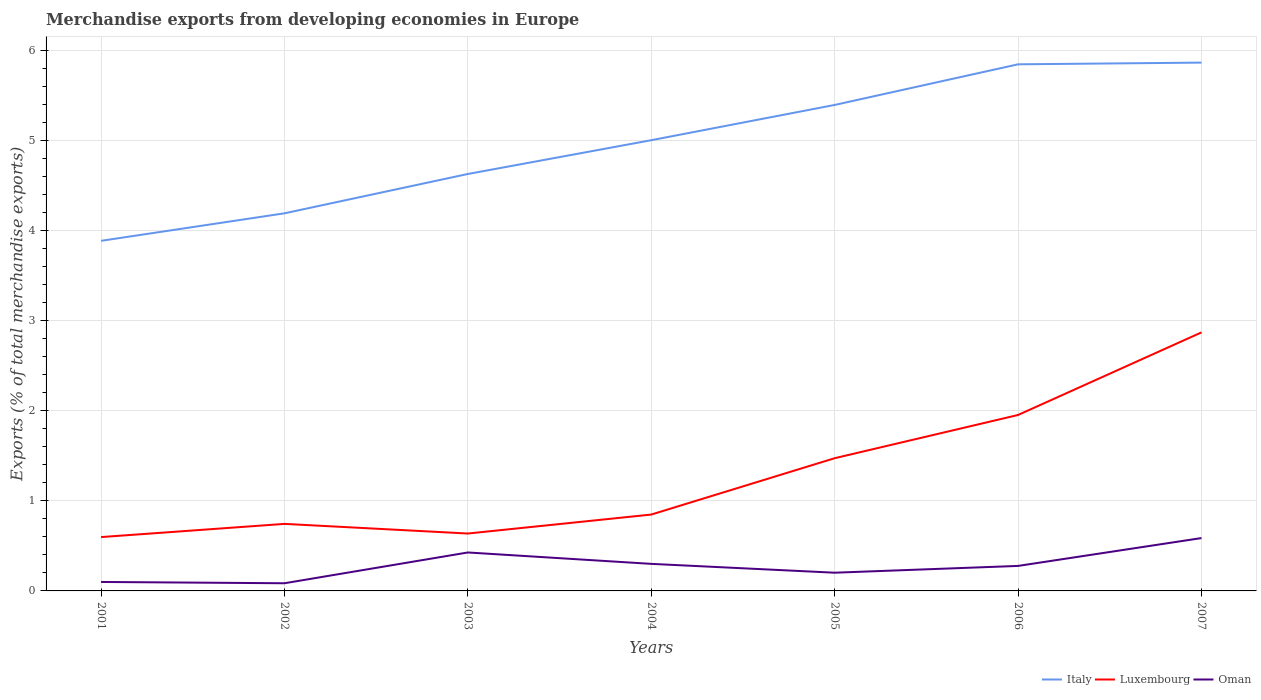Does the line corresponding to Oman intersect with the line corresponding to Italy?
Provide a short and direct response. No. Across all years, what is the maximum percentage of total merchandise exports in Luxembourg?
Provide a short and direct response. 0.6. What is the total percentage of total merchandise exports in Luxembourg in the graph?
Provide a short and direct response. -0.84. What is the difference between the highest and the second highest percentage of total merchandise exports in Luxembourg?
Ensure brevity in your answer.  2.27. How many lines are there?
Your answer should be compact. 3. How many legend labels are there?
Give a very brief answer. 3. How are the legend labels stacked?
Make the answer very short. Horizontal. What is the title of the graph?
Your answer should be compact. Merchandise exports from developing economies in Europe. What is the label or title of the X-axis?
Keep it short and to the point. Years. What is the label or title of the Y-axis?
Provide a short and direct response. Exports (% of total merchandise exports). What is the Exports (% of total merchandise exports) in Italy in 2001?
Offer a very short reply. 3.89. What is the Exports (% of total merchandise exports) of Luxembourg in 2001?
Provide a short and direct response. 0.6. What is the Exports (% of total merchandise exports) of Oman in 2001?
Offer a terse response. 0.1. What is the Exports (% of total merchandise exports) in Italy in 2002?
Make the answer very short. 4.19. What is the Exports (% of total merchandise exports) of Luxembourg in 2002?
Your answer should be very brief. 0.74. What is the Exports (% of total merchandise exports) of Oman in 2002?
Your answer should be very brief. 0.09. What is the Exports (% of total merchandise exports) in Italy in 2003?
Provide a short and direct response. 4.63. What is the Exports (% of total merchandise exports) of Luxembourg in 2003?
Offer a terse response. 0.64. What is the Exports (% of total merchandise exports) of Oman in 2003?
Offer a very short reply. 0.43. What is the Exports (% of total merchandise exports) in Italy in 2004?
Offer a very short reply. 5.01. What is the Exports (% of total merchandise exports) in Luxembourg in 2004?
Provide a short and direct response. 0.85. What is the Exports (% of total merchandise exports) in Oman in 2004?
Keep it short and to the point. 0.3. What is the Exports (% of total merchandise exports) of Italy in 2005?
Your answer should be compact. 5.4. What is the Exports (% of total merchandise exports) in Luxembourg in 2005?
Offer a terse response. 1.47. What is the Exports (% of total merchandise exports) in Oman in 2005?
Offer a very short reply. 0.2. What is the Exports (% of total merchandise exports) of Italy in 2006?
Provide a succinct answer. 5.85. What is the Exports (% of total merchandise exports) in Luxembourg in 2006?
Offer a terse response. 1.95. What is the Exports (% of total merchandise exports) of Oman in 2006?
Give a very brief answer. 0.28. What is the Exports (% of total merchandise exports) in Italy in 2007?
Provide a succinct answer. 5.87. What is the Exports (% of total merchandise exports) in Luxembourg in 2007?
Offer a very short reply. 2.87. What is the Exports (% of total merchandise exports) in Oman in 2007?
Make the answer very short. 0.59. Across all years, what is the maximum Exports (% of total merchandise exports) in Italy?
Provide a succinct answer. 5.87. Across all years, what is the maximum Exports (% of total merchandise exports) in Luxembourg?
Your answer should be very brief. 2.87. Across all years, what is the maximum Exports (% of total merchandise exports) in Oman?
Your response must be concise. 0.59. Across all years, what is the minimum Exports (% of total merchandise exports) in Italy?
Provide a short and direct response. 3.89. Across all years, what is the minimum Exports (% of total merchandise exports) of Luxembourg?
Make the answer very short. 0.6. Across all years, what is the minimum Exports (% of total merchandise exports) in Oman?
Give a very brief answer. 0.09. What is the total Exports (% of total merchandise exports) of Italy in the graph?
Make the answer very short. 34.83. What is the total Exports (% of total merchandise exports) of Luxembourg in the graph?
Offer a terse response. 9.13. What is the total Exports (% of total merchandise exports) in Oman in the graph?
Make the answer very short. 1.98. What is the difference between the Exports (% of total merchandise exports) of Italy in 2001 and that in 2002?
Your answer should be compact. -0.31. What is the difference between the Exports (% of total merchandise exports) of Luxembourg in 2001 and that in 2002?
Your response must be concise. -0.15. What is the difference between the Exports (% of total merchandise exports) in Oman in 2001 and that in 2002?
Offer a very short reply. 0.01. What is the difference between the Exports (% of total merchandise exports) of Italy in 2001 and that in 2003?
Ensure brevity in your answer.  -0.74. What is the difference between the Exports (% of total merchandise exports) in Luxembourg in 2001 and that in 2003?
Your response must be concise. -0.04. What is the difference between the Exports (% of total merchandise exports) in Oman in 2001 and that in 2003?
Provide a short and direct response. -0.33. What is the difference between the Exports (% of total merchandise exports) in Italy in 2001 and that in 2004?
Your answer should be compact. -1.12. What is the difference between the Exports (% of total merchandise exports) of Luxembourg in 2001 and that in 2004?
Your response must be concise. -0.25. What is the difference between the Exports (% of total merchandise exports) of Oman in 2001 and that in 2004?
Your answer should be compact. -0.2. What is the difference between the Exports (% of total merchandise exports) in Italy in 2001 and that in 2005?
Your answer should be compact. -1.51. What is the difference between the Exports (% of total merchandise exports) of Luxembourg in 2001 and that in 2005?
Keep it short and to the point. -0.88. What is the difference between the Exports (% of total merchandise exports) in Oman in 2001 and that in 2005?
Make the answer very short. -0.1. What is the difference between the Exports (% of total merchandise exports) in Italy in 2001 and that in 2006?
Keep it short and to the point. -1.96. What is the difference between the Exports (% of total merchandise exports) of Luxembourg in 2001 and that in 2006?
Provide a succinct answer. -1.36. What is the difference between the Exports (% of total merchandise exports) of Oman in 2001 and that in 2006?
Ensure brevity in your answer.  -0.18. What is the difference between the Exports (% of total merchandise exports) of Italy in 2001 and that in 2007?
Keep it short and to the point. -1.98. What is the difference between the Exports (% of total merchandise exports) of Luxembourg in 2001 and that in 2007?
Provide a succinct answer. -2.27. What is the difference between the Exports (% of total merchandise exports) in Oman in 2001 and that in 2007?
Provide a succinct answer. -0.49. What is the difference between the Exports (% of total merchandise exports) of Italy in 2002 and that in 2003?
Provide a succinct answer. -0.44. What is the difference between the Exports (% of total merchandise exports) of Luxembourg in 2002 and that in 2003?
Offer a very short reply. 0.11. What is the difference between the Exports (% of total merchandise exports) of Oman in 2002 and that in 2003?
Offer a very short reply. -0.34. What is the difference between the Exports (% of total merchandise exports) in Italy in 2002 and that in 2004?
Make the answer very short. -0.81. What is the difference between the Exports (% of total merchandise exports) in Luxembourg in 2002 and that in 2004?
Ensure brevity in your answer.  -0.1. What is the difference between the Exports (% of total merchandise exports) of Oman in 2002 and that in 2004?
Your answer should be very brief. -0.22. What is the difference between the Exports (% of total merchandise exports) of Italy in 2002 and that in 2005?
Your answer should be compact. -1.2. What is the difference between the Exports (% of total merchandise exports) of Luxembourg in 2002 and that in 2005?
Provide a succinct answer. -0.73. What is the difference between the Exports (% of total merchandise exports) in Oman in 2002 and that in 2005?
Offer a very short reply. -0.12. What is the difference between the Exports (% of total merchandise exports) of Italy in 2002 and that in 2006?
Your answer should be compact. -1.65. What is the difference between the Exports (% of total merchandise exports) in Luxembourg in 2002 and that in 2006?
Your answer should be very brief. -1.21. What is the difference between the Exports (% of total merchandise exports) in Oman in 2002 and that in 2006?
Give a very brief answer. -0.19. What is the difference between the Exports (% of total merchandise exports) of Italy in 2002 and that in 2007?
Your answer should be very brief. -1.67. What is the difference between the Exports (% of total merchandise exports) of Luxembourg in 2002 and that in 2007?
Your answer should be compact. -2.13. What is the difference between the Exports (% of total merchandise exports) of Oman in 2002 and that in 2007?
Make the answer very short. -0.5. What is the difference between the Exports (% of total merchandise exports) of Italy in 2003 and that in 2004?
Ensure brevity in your answer.  -0.38. What is the difference between the Exports (% of total merchandise exports) of Luxembourg in 2003 and that in 2004?
Keep it short and to the point. -0.21. What is the difference between the Exports (% of total merchandise exports) in Oman in 2003 and that in 2004?
Your answer should be compact. 0.13. What is the difference between the Exports (% of total merchandise exports) in Italy in 2003 and that in 2005?
Ensure brevity in your answer.  -0.77. What is the difference between the Exports (% of total merchandise exports) in Luxembourg in 2003 and that in 2005?
Keep it short and to the point. -0.84. What is the difference between the Exports (% of total merchandise exports) of Oman in 2003 and that in 2005?
Your answer should be compact. 0.22. What is the difference between the Exports (% of total merchandise exports) in Italy in 2003 and that in 2006?
Make the answer very short. -1.22. What is the difference between the Exports (% of total merchandise exports) of Luxembourg in 2003 and that in 2006?
Offer a terse response. -1.32. What is the difference between the Exports (% of total merchandise exports) in Oman in 2003 and that in 2006?
Provide a succinct answer. 0.15. What is the difference between the Exports (% of total merchandise exports) of Italy in 2003 and that in 2007?
Keep it short and to the point. -1.24. What is the difference between the Exports (% of total merchandise exports) in Luxembourg in 2003 and that in 2007?
Offer a very short reply. -2.23. What is the difference between the Exports (% of total merchandise exports) in Oman in 2003 and that in 2007?
Offer a terse response. -0.16. What is the difference between the Exports (% of total merchandise exports) of Italy in 2004 and that in 2005?
Provide a succinct answer. -0.39. What is the difference between the Exports (% of total merchandise exports) of Luxembourg in 2004 and that in 2005?
Keep it short and to the point. -0.63. What is the difference between the Exports (% of total merchandise exports) of Oman in 2004 and that in 2005?
Your answer should be very brief. 0.1. What is the difference between the Exports (% of total merchandise exports) in Italy in 2004 and that in 2006?
Offer a terse response. -0.84. What is the difference between the Exports (% of total merchandise exports) of Luxembourg in 2004 and that in 2006?
Offer a terse response. -1.11. What is the difference between the Exports (% of total merchandise exports) in Oman in 2004 and that in 2006?
Make the answer very short. 0.02. What is the difference between the Exports (% of total merchandise exports) in Italy in 2004 and that in 2007?
Offer a very short reply. -0.86. What is the difference between the Exports (% of total merchandise exports) of Luxembourg in 2004 and that in 2007?
Your response must be concise. -2.02. What is the difference between the Exports (% of total merchandise exports) of Oman in 2004 and that in 2007?
Give a very brief answer. -0.29. What is the difference between the Exports (% of total merchandise exports) of Italy in 2005 and that in 2006?
Provide a short and direct response. -0.45. What is the difference between the Exports (% of total merchandise exports) of Luxembourg in 2005 and that in 2006?
Provide a succinct answer. -0.48. What is the difference between the Exports (% of total merchandise exports) of Oman in 2005 and that in 2006?
Your answer should be very brief. -0.08. What is the difference between the Exports (% of total merchandise exports) of Italy in 2005 and that in 2007?
Your answer should be very brief. -0.47. What is the difference between the Exports (% of total merchandise exports) of Luxembourg in 2005 and that in 2007?
Your response must be concise. -1.4. What is the difference between the Exports (% of total merchandise exports) in Oman in 2005 and that in 2007?
Provide a short and direct response. -0.38. What is the difference between the Exports (% of total merchandise exports) of Italy in 2006 and that in 2007?
Offer a terse response. -0.02. What is the difference between the Exports (% of total merchandise exports) in Luxembourg in 2006 and that in 2007?
Ensure brevity in your answer.  -0.92. What is the difference between the Exports (% of total merchandise exports) in Oman in 2006 and that in 2007?
Your response must be concise. -0.31. What is the difference between the Exports (% of total merchandise exports) in Italy in 2001 and the Exports (% of total merchandise exports) in Luxembourg in 2002?
Provide a short and direct response. 3.14. What is the difference between the Exports (% of total merchandise exports) of Italy in 2001 and the Exports (% of total merchandise exports) of Oman in 2002?
Your answer should be compact. 3.8. What is the difference between the Exports (% of total merchandise exports) of Luxembourg in 2001 and the Exports (% of total merchandise exports) of Oman in 2002?
Provide a short and direct response. 0.51. What is the difference between the Exports (% of total merchandise exports) of Italy in 2001 and the Exports (% of total merchandise exports) of Luxembourg in 2003?
Ensure brevity in your answer.  3.25. What is the difference between the Exports (% of total merchandise exports) of Italy in 2001 and the Exports (% of total merchandise exports) of Oman in 2003?
Provide a short and direct response. 3.46. What is the difference between the Exports (% of total merchandise exports) in Luxembourg in 2001 and the Exports (% of total merchandise exports) in Oman in 2003?
Keep it short and to the point. 0.17. What is the difference between the Exports (% of total merchandise exports) of Italy in 2001 and the Exports (% of total merchandise exports) of Luxembourg in 2004?
Keep it short and to the point. 3.04. What is the difference between the Exports (% of total merchandise exports) in Italy in 2001 and the Exports (% of total merchandise exports) in Oman in 2004?
Offer a very short reply. 3.59. What is the difference between the Exports (% of total merchandise exports) in Luxembourg in 2001 and the Exports (% of total merchandise exports) in Oman in 2004?
Give a very brief answer. 0.3. What is the difference between the Exports (% of total merchandise exports) of Italy in 2001 and the Exports (% of total merchandise exports) of Luxembourg in 2005?
Ensure brevity in your answer.  2.41. What is the difference between the Exports (% of total merchandise exports) in Italy in 2001 and the Exports (% of total merchandise exports) in Oman in 2005?
Make the answer very short. 3.69. What is the difference between the Exports (% of total merchandise exports) of Luxembourg in 2001 and the Exports (% of total merchandise exports) of Oman in 2005?
Ensure brevity in your answer.  0.4. What is the difference between the Exports (% of total merchandise exports) in Italy in 2001 and the Exports (% of total merchandise exports) in Luxembourg in 2006?
Offer a very short reply. 1.93. What is the difference between the Exports (% of total merchandise exports) of Italy in 2001 and the Exports (% of total merchandise exports) of Oman in 2006?
Your response must be concise. 3.61. What is the difference between the Exports (% of total merchandise exports) in Luxembourg in 2001 and the Exports (% of total merchandise exports) in Oman in 2006?
Your answer should be very brief. 0.32. What is the difference between the Exports (% of total merchandise exports) of Italy in 2001 and the Exports (% of total merchandise exports) of Luxembourg in 2007?
Ensure brevity in your answer.  1.02. What is the difference between the Exports (% of total merchandise exports) in Italy in 2001 and the Exports (% of total merchandise exports) in Oman in 2007?
Make the answer very short. 3.3. What is the difference between the Exports (% of total merchandise exports) of Luxembourg in 2001 and the Exports (% of total merchandise exports) of Oman in 2007?
Your response must be concise. 0.01. What is the difference between the Exports (% of total merchandise exports) of Italy in 2002 and the Exports (% of total merchandise exports) of Luxembourg in 2003?
Offer a very short reply. 3.56. What is the difference between the Exports (% of total merchandise exports) in Italy in 2002 and the Exports (% of total merchandise exports) in Oman in 2003?
Provide a succinct answer. 3.77. What is the difference between the Exports (% of total merchandise exports) in Luxembourg in 2002 and the Exports (% of total merchandise exports) in Oman in 2003?
Give a very brief answer. 0.32. What is the difference between the Exports (% of total merchandise exports) in Italy in 2002 and the Exports (% of total merchandise exports) in Luxembourg in 2004?
Your answer should be compact. 3.35. What is the difference between the Exports (% of total merchandise exports) in Italy in 2002 and the Exports (% of total merchandise exports) in Oman in 2004?
Offer a terse response. 3.89. What is the difference between the Exports (% of total merchandise exports) in Luxembourg in 2002 and the Exports (% of total merchandise exports) in Oman in 2004?
Provide a succinct answer. 0.44. What is the difference between the Exports (% of total merchandise exports) in Italy in 2002 and the Exports (% of total merchandise exports) in Luxembourg in 2005?
Your answer should be very brief. 2.72. What is the difference between the Exports (% of total merchandise exports) in Italy in 2002 and the Exports (% of total merchandise exports) in Oman in 2005?
Your answer should be very brief. 3.99. What is the difference between the Exports (% of total merchandise exports) of Luxembourg in 2002 and the Exports (% of total merchandise exports) of Oman in 2005?
Offer a very short reply. 0.54. What is the difference between the Exports (% of total merchandise exports) in Italy in 2002 and the Exports (% of total merchandise exports) in Luxembourg in 2006?
Offer a very short reply. 2.24. What is the difference between the Exports (% of total merchandise exports) of Italy in 2002 and the Exports (% of total merchandise exports) of Oman in 2006?
Your answer should be very brief. 3.92. What is the difference between the Exports (% of total merchandise exports) of Luxembourg in 2002 and the Exports (% of total merchandise exports) of Oman in 2006?
Provide a short and direct response. 0.47. What is the difference between the Exports (% of total merchandise exports) in Italy in 2002 and the Exports (% of total merchandise exports) in Luxembourg in 2007?
Make the answer very short. 1.32. What is the difference between the Exports (% of total merchandise exports) of Italy in 2002 and the Exports (% of total merchandise exports) of Oman in 2007?
Provide a short and direct response. 3.61. What is the difference between the Exports (% of total merchandise exports) in Luxembourg in 2002 and the Exports (% of total merchandise exports) in Oman in 2007?
Give a very brief answer. 0.16. What is the difference between the Exports (% of total merchandise exports) in Italy in 2003 and the Exports (% of total merchandise exports) in Luxembourg in 2004?
Offer a very short reply. 3.78. What is the difference between the Exports (% of total merchandise exports) in Italy in 2003 and the Exports (% of total merchandise exports) in Oman in 2004?
Provide a short and direct response. 4.33. What is the difference between the Exports (% of total merchandise exports) in Luxembourg in 2003 and the Exports (% of total merchandise exports) in Oman in 2004?
Give a very brief answer. 0.34. What is the difference between the Exports (% of total merchandise exports) of Italy in 2003 and the Exports (% of total merchandise exports) of Luxembourg in 2005?
Provide a short and direct response. 3.16. What is the difference between the Exports (% of total merchandise exports) of Italy in 2003 and the Exports (% of total merchandise exports) of Oman in 2005?
Give a very brief answer. 4.43. What is the difference between the Exports (% of total merchandise exports) of Luxembourg in 2003 and the Exports (% of total merchandise exports) of Oman in 2005?
Ensure brevity in your answer.  0.44. What is the difference between the Exports (% of total merchandise exports) in Italy in 2003 and the Exports (% of total merchandise exports) in Luxembourg in 2006?
Provide a succinct answer. 2.68. What is the difference between the Exports (% of total merchandise exports) of Italy in 2003 and the Exports (% of total merchandise exports) of Oman in 2006?
Your answer should be compact. 4.35. What is the difference between the Exports (% of total merchandise exports) of Luxembourg in 2003 and the Exports (% of total merchandise exports) of Oman in 2006?
Your response must be concise. 0.36. What is the difference between the Exports (% of total merchandise exports) in Italy in 2003 and the Exports (% of total merchandise exports) in Luxembourg in 2007?
Provide a short and direct response. 1.76. What is the difference between the Exports (% of total merchandise exports) in Italy in 2003 and the Exports (% of total merchandise exports) in Oman in 2007?
Offer a very short reply. 4.04. What is the difference between the Exports (% of total merchandise exports) of Luxembourg in 2003 and the Exports (% of total merchandise exports) of Oman in 2007?
Your answer should be very brief. 0.05. What is the difference between the Exports (% of total merchandise exports) of Italy in 2004 and the Exports (% of total merchandise exports) of Luxembourg in 2005?
Your answer should be very brief. 3.53. What is the difference between the Exports (% of total merchandise exports) in Italy in 2004 and the Exports (% of total merchandise exports) in Oman in 2005?
Make the answer very short. 4.8. What is the difference between the Exports (% of total merchandise exports) of Luxembourg in 2004 and the Exports (% of total merchandise exports) of Oman in 2005?
Keep it short and to the point. 0.65. What is the difference between the Exports (% of total merchandise exports) in Italy in 2004 and the Exports (% of total merchandise exports) in Luxembourg in 2006?
Provide a short and direct response. 3.05. What is the difference between the Exports (% of total merchandise exports) of Italy in 2004 and the Exports (% of total merchandise exports) of Oman in 2006?
Give a very brief answer. 4.73. What is the difference between the Exports (% of total merchandise exports) of Luxembourg in 2004 and the Exports (% of total merchandise exports) of Oman in 2006?
Offer a terse response. 0.57. What is the difference between the Exports (% of total merchandise exports) of Italy in 2004 and the Exports (% of total merchandise exports) of Luxembourg in 2007?
Provide a succinct answer. 2.13. What is the difference between the Exports (% of total merchandise exports) of Italy in 2004 and the Exports (% of total merchandise exports) of Oman in 2007?
Your answer should be compact. 4.42. What is the difference between the Exports (% of total merchandise exports) of Luxembourg in 2004 and the Exports (% of total merchandise exports) of Oman in 2007?
Offer a very short reply. 0.26. What is the difference between the Exports (% of total merchandise exports) of Italy in 2005 and the Exports (% of total merchandise exports) of Luxembourg in 2006?
Provide a short and direct response. 3.44. What is the difference between the Exports (% of total merchandise exports) of Italy in 2005 and the Exports (% of total merchandise exports) of Oman in 2006?
Your response must be concise. 5.12. What is the difference between the Exports (% of total merchandise exports) of Luxembourg in 2005 and the Exports (% of total merchandise exports) of Oman in 2006?
Your answer should be compact. 1.2. What is the difference between the Exports (% of total merchandise exports) of Italy in 2005 and the Exports (% of total merchandise exports) of Luxembourg in 2007?
Your response must be concise. 2.53. What is the difference between the Exports (% of total merchandise exports) of Italy in 2005 and the Exports (% of total merchandise exports) of Oman in 2007?
Give a very brief answer. 4.81. What is the difference between the Exports (% of total merchandise exports) of Luxembourg in 2005 and the Exports (% of total merchandise exports) of Oman in 2007?
Keep it short and to the point. 0.89. What is the difference between the Exports (% of total merchandise exports) of Italy in 2006 and the Exports (% of total merchandise exports) of Luxembourg in 2007?
Keep it short and to the point. 2.98. What is the difference between the Exports (% of total merchandise exports) in Italy in 2006 and the Exports (% of total merchandise exports) in Oman in 2007?
Give a very brief answer. 5.26. What is the difference between the Exports (% of total merchandise exports) in Luxembourg in 2006 and the Exports (% of total merchandise exports) in Oman in 2007?
Offer a very short reply. 1.37. What is the average Exports (% of total merchandise exports) in Italy per year?
Offer a terse response. 4.98. What is the average Exports (% of total merchandise exports) of Luxembourg per year?
Make the answer very short. 1.3. What is the average Exports (% of total merchandise exports) of Oman per year?
Offer a terse response. 0.28. In the year 2001, what is the difference between the Exports (% of total merchandise exports) of Italy and Exports (% of total merchandise exports) of Luxembourg?
Make the answer very short. 3.29. In the year 2001, what is the difference between the Exports (% of total merchandise exports) in Italy and Exports (% of total merchandise exports) in Oman?
Keep it short and to the point. 3.79. In the year 2001, what is the difference between the Exports (% of total merchandise exports) of Luxembourg and Exports (% of total merchandise exports) of Oman?
Offer a very short reply. 0.5. In the year 2002, what is the difference between the Exports (% of total merchandise exports) of Italy and Exports (% of total merchandise exports) of Luxembourg?
Your answer should be compact. 3.45. In the year 2002, what is the difference between the Exports (% of total merchandise exports) in Italy and Exports (% of total merchandise exports) in Oman?
Ensure brevity in your answer.  4.11. In the year 2002, what is the difference between the Exports (% of total merchandise exports) in Luxembourg and Exports (% of total merchandise exports) in Oman?
Offer a terse response. 0.66. In the year 2003, what is the difference between the Exports (% of total merchandise exports) of Italy and Exports (% of total merchandise exports) of Luxembourg?
Your answer should be compact. 3.99. In the year 2003, what is the difference between the Exports (% of total merchandise exports) in Italy and Exports (% of total merchandise exports) in Oman?
Provide a succinct answer. 4.2. In the year 2003, what is the difference between the Exports (% of total merchandise exports) of Luxembourg and Exports (% of total merchandise exports) of Oman?
Provide a succinct answer. 0.21. In the year 2004, what is the difference between the Exports (% of total merchandise exports) in Italy and Exports (% of total merchandise exports) in Luxembourg?
Offer a terse response. 4.16. In the year 2004, what is the difference between the Exports (% of total merchandise exports) of Italy and Exports (% of total merchandise exports) of Oman?
Keep it short and to the point. 4.7. In the year 2004, what is the difference between the Exports (% of total merchandise exports) in Luxembourg and Exports (% of total merchandise exports) in Oman?
Your answer should be compact. 0.55. In the year 2005, what is the difference between the Exports (% of total merchandise exports) of Italy and Exports (% of total merchandise exports) of Luxembourg?
Keep it short and to the point. 3.92. In the year 2005, what is the difference between the Exports (% of total merchandise exports) in Italy and Exports (% of total merchandise exports) in Oman?
Your response must be concise. 5.19. In the year 2005, what is the difference between the Exports (% of total merchandise exports) of Luxembourg and Exports (% of total merchandise exports) of Oman?
Offer a very short reply. 1.27. In the year 2006, what is the difference between the Exports (% of total merchandise exports) of Italy and Exports (% of total merchandise exports) of Luxembourg?
Ensure brevity in your answer.  3.89. In the year 2006, what is the difference between the Exports (% of total merchandise exports) of Italy and Exports (% of total merchandise exports) of Oman?
Offer a terse response. 5.57. In the year 2006, what is the difference between the Exports (% of total merchandise exports) in Luxembourg and Exports (% of total merchandise exports) in Oman?
Your answer should be very brief. 1.68. In the year 2007, what is the difference between the Exports (% of total merchandise exports) in Italy and Exports (% of total merchandise exports) in Luxembourg?
Ensure brevity in your answer.  3. In the year 2007, what is the difference between the Exports (% of total merchandise exports) in Italy and Exports (% of total merchandise exports) in Oman?
Your answer should be compact. 5.28. In the year 2007, what is the difference between the Exports (% of total merchandise exports) in Luxembourg and Exports (% of total merchandise exports) in Oman?
Provide a short and direct response. 2.28. What is the ratio of the Exports (% of total merchandise exports) in Italy in 2001 to that in 2002?
Keep it short and to the point. 0.93. What is the ratio of the Exports (% of total merchandise exports) in Luxembourg in 2001 to that in 2002?
Give a very brief answer. 0.8. What is the ratio of the Exports (% of total merchandise exports) of Oman in 2001 to that in 2002?
Provide a short and direct response. 1.17. What is the ratio of the Exports (% of total merchandise exports) in Italy in 2001 to that in 2003?
Keep it short and to the point. 0.84. What is the ratio of the Exports (% of total merchandise exports) in Luxembourg in 2001 to that in 2003?
Your answer should be very brief. 0.94. What is the ratio of the Exports (% of total merchandise exports) of Oman in 2001 to that in 2003?
Provide a succinct answer. 0.23. What is the ratio of the Exports (% of total merchandise exports) in Italy in 2001 to that in 2004?
Provide a short and direct response. 0.78. What is the ratio of the Exports (% of total merchandise exports) in Luxembourg in 2001 to that in 2004?
Your answer should be compact. 0.7. What is the ratio of the Exports (% of total merchandise exports) in Oman in 2001 to that in 2004?
Offer a terse response. 0.33. What is the ratio of the Exports (% of total merchandise exports) of Italy in 2001 to that in 2005?
Provide a short and direct response. 0.72. What is the ratio of the Exports (% of total merchandise exports) of Luxembourg in 2001 to that in 2005?
Your answer should be very brief. 0.41. What is the ratio of the Exports (% of total merchandise exports) of Oman in 2001 to that in 2005?
Provide a short and direct response. 0.49. What is the ratio of the Exports (% of total merchandise exports) in Italy in 2001 to that in 2006?
Ensure brevity in your answer.  0.66. What is the ratio of the Exports (% of total merchandise exports) in Luxembourg in 2001 to that in 2006?
Ensure brevity in your answer.  0.31. What is the ratio of the Exports (% of total merchandise exports) in Oman in 2001 to that in 2006?
Offer a very short reply. 0.36. What is the ratio of the Exports (% of total merchandise exports) in Italy in 2001 to that in 2007?
Your answer should be very brief. 0.66. What is the ratio of the Exports (% of total merchandise exports) of Luxembourg in 2001 to that in 2007?
Offer a terse response. 0.21. What is the ratio of the Exports (% of total merchandise exports) of Oman in 2001 to that in 2007?
Offer a terse response. 0.17. What is the ratio of the Exports (% of total merchandise exports) of Italy in 2002 to that in 2003?
Give a very brief answer. 0.91. What is the ratio of the Exports (% of total merchandise exports) in Luxembourg in 2002 to that in 2003?
Make the answer very short. 1.17. What is the ratio of the Exports (% of total merchandise exports) of Oman in 2002 to that in 2003?
Make the answer very short. 0.2. What is the ratio of the Exports (% of total merchandise exports) of Italy in 2002 to that in 2004?
Ensure brevity in your answer.  0.84. What is the ratio of the Exports (% of total merchandise exports) in Luxembourg in 2002 to that in 2004?
Provide a short and direct response. 0.88. What is the ratio of the Exports (% of total merchandise exports) in Oman in 2002 to that in 2004?
Ensure brevity in your answer.  0.28. What is the ratio of the Exports (% of total merchandise exports) in Italy in 2002 to that in 2005?
Provide a short and direct response. 0.78. What is the ratio of the Exports (% of total merchandise exports) of Luxembourg in 2002 to that in 2005?
Your response must be concise. 0.51. What is the ratio of the Exports (% of total merchandise exports) of Oman in 2002 to that in 2005?
Your answer should be compact. 0.42. What is the ratio of the Exports (% of total merchandise exports) in Italy in 2002 to that in 2006?
Give a very brief answer. 0.72. What is the ratio of the Exports (% of total merchandise exports) in Luxembourg in 2002 to that in 2006?
Your response must be concise. 0.38. What is the ratio of the Exports (% of total merchandise exports) in Oman in 2002 to that in 2006?
Keep it short and to the point. 0.31. What is the ratio of the Exports (% of total merchandise exports) in Italy in 2002 to that in 2007?
Your answer should be very brief. 0.71. What is the ratio of the Exports (% of total merchandise exports) in Luxembourg in 2002 to that in 2007?
Ensure brevity in your answer.  0.26. What is the ratio of the Exports (% of total merchandise exports) in Oman in 2002 to that in 2007?
Your response must be concise. 0.14. What is the ratio of the Exports (% of total merchandise exports) of Italy in 2003 to that in 2004?
Offer a terse response. 0.93. What is the ratio of the Exports (% of total merchandise exports) of Luxembourg in 2003 to that in 2004?
Offer a terse response. 0.75. What is the ratio of the Exports (% of total merchandise exports) in Oman in 2003 to that in 2004?
Your answer should be compact. 1.42. What is the ratio of the Exports (% of total merchandise exports) in Italy in 2003 to that in 2005?
Give a very brief answer. 0.86. What is the ratio of the Exports (% of total merchandise exports) in Luxembourg in 2003 to that in 2005?
Give a very brief answer. 0.43. What is the ratio of the Exports (% of total merchandise exports) in Oman in 2003 to that in 2005?
Make the answer very short. 2.11. What is the ratio of the Exports (% of total merchandise exports) of Italy in 2003 to that in 2006?
Offer a terse response. 0.79. What is the ratio of the Exports (% of total merchandise exports) in Luxembourg in 2003 to that in 2006?
Provide a short and direct response. 0.33. What is the ratio of the Exports (% of total merchandise exports) in Oman in 2003 to that in 2006?
Your answer should be very brief. 1.54. What is the ratio of the Exports (% of total merchandise exports) of Italy in 2003 to that in 2007?
Give a very brief answer. 0.79. What is the ratio of the Exports (% of total merchandise exports) in Luxembourg in 2003 to that in 2007?
Ensure brevity in your answer.  0.22. What is the ratio of the Exports (% of total merchandise exports) of Oman in 2003 to that in 2007?
Give a very brief answer. 0.73. What is the ratio of the Exports (% of total merchandise exports) in Italy in 2004 to that in 2005?
Your response must be concise. 0.93. What is the ratio of the Exports (% of total merchandise exports) of Luxembourg in 2004 to that in 2005?
Ensure brevity in your answer.  0.58. What is the ratio of the Exports (% of total merchandise exports) of Oman in 2004 to that in 2005?
Your answer should be very brief. 1.49. What is the ratio of the Exports (% of total merchandise exports) in Italy in 2004 to that in 2006?
Your response must be concise. 0.86. What is the ratio of the Exports (% of total merchandise exports) in Luxembourg in 2004 to that in 2006?
Give a very brief answer. 0.43. What is the ratio of the Exports (% of total merchandise exports) in Oman in 2004 to that in 2006?
Your answer should be very brief. 1.08. What is the ratio of the Exports (% of total merchandise exports) in Italy in 2004 to that in 2007?
Offer a very short reply. 0.85. What is the ratio of the Exports (% of total merchandise exports) in Luxembourg in 2004 to that in 2007?
Ensure brevity in your answer.  0.3. What is the ratio of the Exports (% of total merchandise exports) of Oman in 2004 to that in 2007?
Give a very brief answer. 0.51. What is the ratio of the Exports (% of total merchandise exports) in Italy in 2005 to that in 2006?
Your answer should be very brief. 0.92. What is the ratio of the Exports (% of total merchandise exports) of Luxembourg in 2005 to that in 2006?
Your response must be concise. 0.75. What is the ratio of the Exports (% of total merchandise exports) in Oman in 2005 to that in 2006?
Provide a short and direct response. 0.73. What is the ratio of the Exports (% of total merchandise exports) of Italy in 2005 to that in 2007?
Ensure brevity in your answer.  0.92. What is the ratio of the Exports (% of total merchandise exports) of Luxembourg in 2005 to that in 2007?
Your response must be concise. 0.51. What is the ratio of the Exports (% of total merchandise exports) of Oman in 2005 to that in 2007?
Your response must be concise. 0.34. What is the ratio of the Exports (% of total merchandise exports) in Luxembourg in 2006 to that in 2007?
Your answer should be compact. 0.68. What is the ratio of the Exports (% of total merchandise exports) in Oman in 2006 to that in 2007?
Your answer should be compact. 0.47. What is the difference between the highest and the second highest Exports (% of total merchandise exports) in Italy?
Give a very brief answer. 0.02. What is the difference between the highest and the second highest Exports (% of total merchandise exports) in Luxembourg?
Your response must be concise. 0.92. What is the difference between the highest and the second highest Exports (% of total merchandise exports) of Oman?
Your answer should be very brief. 0.16. What is the difference between the highest and the lowest Exports (% of total merchandise exports) of Italy?
Provide a short and direct response. 1.98. What is the difference between the highest and the lowest Exports (% of total merchandise exports) of Luxembourg?
Provide a succinct answer. 2.27. What is the difference between the highest and the lowest Exports (% of total merchandise exports) of Oman?
Ensure brevity in your answer.  0.5. 